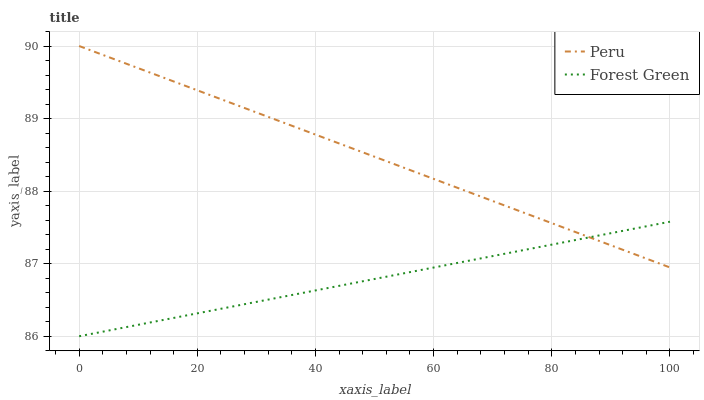Does Forest Green have the minimum area under the curve?
Answer yes or no. Yes. Does Peru have the maximum area under the curve?
Answer yes or no. Yes. Does Peru have the minimum area under the curve?
Answer yes or no. No. Is Forest Green the smoothest?
Answer yes or no. Yes. Is Peru the roughest?
Answer yes or no. Yes. Is Peru the smoothest?
Answer yes or no. No. Does Forest Green have the lowest value?
Answer yes or no. Yes. Does Peru have the lowest value?
Answer yes or no. No. Does Peru have the highest value?
Answer yes or no. Yes. Does Forest Green intersect Peru?
Answer yes or no. Yes. Is Forest Green less than Peru?
Answer yes or no. No. Is Forest Green greater than Peru?
Answer yes or no. No. 